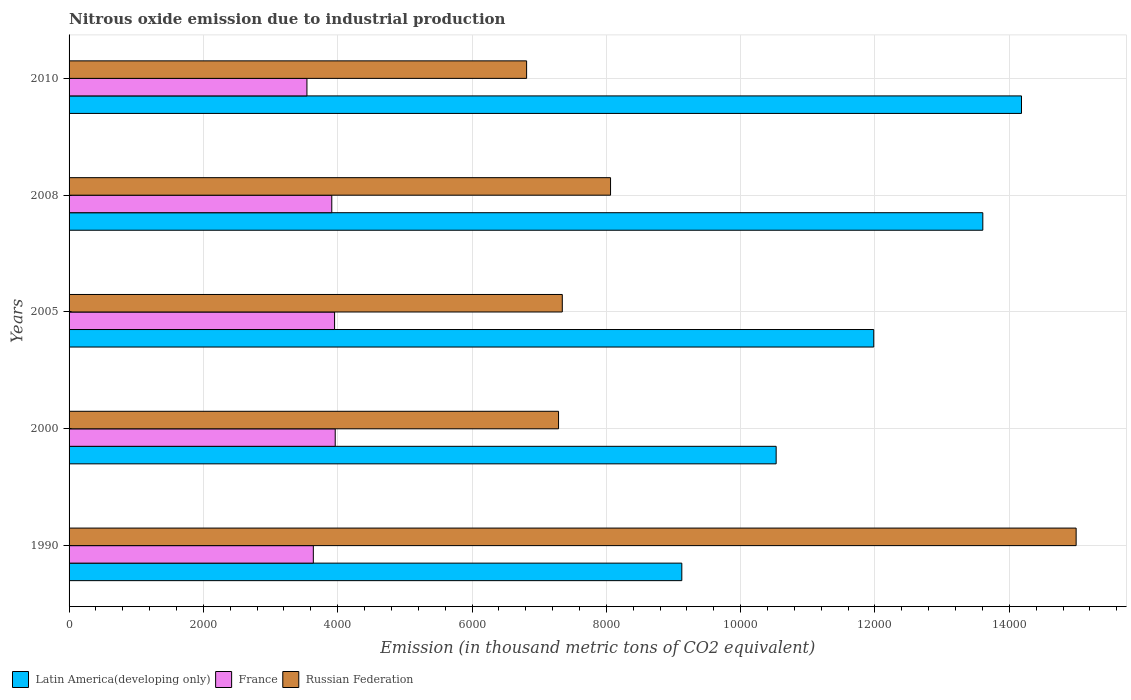How many groups of bars are there?
Make the answer very short. 5. Are the number of bars on each tick of the Y-axis equal?
Provide a succinct answer. Yes. How many bars are there on the 2nd tick from the bottom?
Offer a very short reply. 3. In how many cases, is the number of bars for a given year not equal to the number of legend labels?
Your answer should be very brief. 0. What is the amount of nitrous oxide emitted in Russian Federation in 2000?
Offer a very short reply. 7288.4. Across all years, what is the maximum amount of nitrous oxide emitted in Russian Federation?
Your answer should be very brief. 1.50e+04. Across all years, what is the minimum amount of nitrous oxide emitted in France?
Give a very brief answer. 3541.9. In which year was the amount of nitrous oxide emitted in Latin America(developing only) minimum?
Provide a succinct answer. 1990. What is the total amount of nitrous oxide emitted in Latin America(developing only) in the graph?
Offer a very short reply. 5.94e+04. What is the difference between the amount of nitrous oxide emitted in Latin America(developing only) in 1990 and that in 2005?
Provide a short and direct response. -2858. What is the difference between the amount of nitrous oxide emitted in France in 1990 and the amount of nitrous oxide emitted in Russian Federation in 2008?
Provide a succinct answer. -4425.6. What is the average amount of nitrous oxide emitted in Russian Federation per year?
Offer a terse response. 8900.66. In the year 1990, what is the difference between the amount of nitrous oxide emitted in Latin America(developing only) and amount of nitrous oxide emitted in Russian Federation?
Provide a succinct answer. -5871.5. What is the ratio of the amount of nitrous oxide emitted in France in 2000 to that in 2008?
Make the answer very short. 1.01. What is the difference between the highest and the lowest amount of nitrous oxide emitted in Latin America(developing only)?
Your answer should be very brief. 5058. In how many years, is the amount of nitrous oxide emitted in France greater than the average amount of nitrous oxide emitted in France taken over all years?
Offer a very short reply. 3. What does the 1st bar from the top in 2000 represents?
Keep it short and to the point. Russian Federation. What does the 3rd bar from the bottom in 1990 represents?
Provide a succinct answer. Russian Federation. How many bars are there?
Give a very brief answer. 15. Are the values on the major ticks of X-axis written in scientific E-notation?
Provide a short and direct response. No. Does the graph contain any zero values?
Your response must be concise. No. Does the graph contain grids?
Make the answer very short. Yes. How many legend labels are there?
Offer a terse response. 3. How are the legend labels stacked?
Ensure brevity in your answer.  Horizontal. What is the title of the graph?
Ensure brevity in your answer.  Nitrous oxide emission due to industrial production. What is the label or title of the X-axis?
Ensure brevity in your answer.  Emission (in thousand metric tons of CO2 equivalent). What is the Emission (in thousand metric tons of CO2 equivalent) in Latin America(developing only) in 1990?
Your answer should be compact. 9123.8. What is the Emission (in thousand metric tons of CO2 equivalent) of France in 1990?
Your answer should be compact. 3637.1. What is the Emission (in thousand metric tons of CO2 equivalent) of Russian Federation in 1990?
Offer a very short reply. 1.50e+04. What is the Emission (in thousand metric tons of CO2 equivalent) in Latin America(developing only) in 2000?
Your answer should be very brief. 1.05e+04. What is the Emission (in thousand metric tons of CO2 equivalent) of France in 2000?
Your response must be concise. 3963. What is the Emission (in thousand metric tons of CO2 equivalent) in Russian Federation in 2000?
Offer a terse response. 7288.4. What is the Emission (in thousand metric tons of CO2 equivalent) in Latin America(developing only) in 2005?
Provide a short and direct response. 1.20e+04. What is the Emission (in thousand metric tons of CO2 equivalent) in France in 2005?
Your response must be concise. 3953.5. What is the Emission (in thousand metric tons of CO2 equivalent) in Russian Federation in 2005?
Provide a short and direct response. 7344.1. What is the Emission (in thousand metric tons of CO2 equivalent) in Latin America(developing only) in 2008?
Keep it short and to the point. 1.36e+04. What is the Emission (in thousand metric tons of CO2 equivalent) of France in 2008?
Give a very brief answer. 3911.7. What is the Emission (in thousand metric tons of CO2 equivalent) of Russian Federation in 2008?
Your response must be concise. 8062.7. What is the Emission (in thousand metric tons of CO2 equivalent) in Latin America(developing only) in 2010?
Provide a succinct answer. 1.42e+04. What is the Emission (in thousand metric tons of CO2 equivalent) in France in 2010?
Ensure brevity in your answer.  3541.9. What is the Emission (in thousand metric tons of CO2 equivalent) in Russian Federation in 2010?
Your answer should be very brief. 6812.8. Across all years, what is the maximum Emission (in thousand metric tons of CO2 equivalent) of Latin America(developing only)?
Your response must be concise. 1.42e+04. Across all years, what is the maximum Emission (in thousand metric tons of CO2 equivalent) of France?
Your answer should be compact. 3963. Across all years, what is the maximum Emission (in thousand metric tons of CO2 equivalent) in Russian Federation?
Provide a succinct answer. 1.50e+04. Across all years, what is the minimum Emission (in thousand metric tons of CO2 equivalent) in Latin America(developing only)?
Provide a succinct answer. 9123.8. Across all years, what is the minimum Emission (in thousand metric tons of CO2 equivalent) of France?
Your answer should be compact. 3541.9. Across all years, what is the minimum Emission (in thousand metric tons of CO2 equivalent) of Russian Federation?
Make the answer very short. 6812.8. What is the total Emission (in thousand metric tons of CO2 equivalent) in Latin America(developing only) in the graph?
Provide a succinct answer. 5.94e+04. What is the total Emission (in thousand metric tons of CO2 equivalent) of France in the graph?
Keep it short and to the point. 1.90e+04. What is the total Emission (in thousand metric tons of CO2 equivalent) in Russian Federation in the graph?
Provide a succinct answer. 4.45e+04. What is the difference between the Emission (in thousand metric tons of CO2 equivalent) of Latin America(developing only) in 1990 and that in 2000?
Give a very brief answer. -1404.8. What is the difference between the Emission (in thousand metric tons of CO2 equivalent) of France in 1990 and that in 2000?
Keep it short and to the point. -325.9. What is the difference between the Emission (in thousand metric tons of CO2 equivalent) of Russian Federation in 1990 and that in 2000?
Your response must be concise. 7706.9. What is the difference between the Emission (in thousand metric tons of CO2 equivalent) in Latin America(developing only) in 1990 and that in 2005?
Make the answer very short. -2858. What is the difference between the Emission (in thousand metric tons of CO2 equivalent) of France in 1990 and that in 2005?
Provide a succinct answer. -316.4. What is the difference between the Emission (in thousand metric tons of CO2 equivalent) of Russian Federation in 1990 and that in 2005?
Your answer should be compact. 7651.2. What is the difference between the Emission (in thousand metric tons of CO2 equivalent) of Latin America(developing only) in 1990 and that in 2008?
Your response must be concise. -4481.8. What is the difference between the Emission (in thousand metric tons of CO2 equivalent) in France in 1990 and that in 2008?
Your answer should be very brief. -274.6. What is the difference between the Emission (in thousand metric tons of CO2 equivalent) in Russian Federation in 1990 and that in 2008?
Offer a terse response. 6932.6. What is the difference between the Emission (in thousand metric tons of CO2 equivalent) in Latin America(developing only) in 1990 and that in 2010?
Give a very brief answer. -5058. What is the difference between the Emission (in thousand metric tons of CO2 equivalent) in France in 1990 and that in 2010?
Make the answer very short. 95.2. What is the difference between the Emission (in thousand metric tons of CO2 equivalent) of Russian Federation in 1990 and that in 2010?
Your answer should be compact. 8182.5. What is the difference between the Emission (in thousand metric tons of CO2 equivalent) of Latin America(developing only) in 2000 and that in 2005?
Provide a short and direct response. -1453.2. What is the difference between the Emission (in thousand metric tons of CO2 equivalent) in Russian Federation in 2000 and that in 2005?
Your response must be concise. -55.7. What is the difference between the Emission (in thousand metric tons of CO2 equivalent) of Latin America(developing only) in 2000 and that in 2008?
Ensure brevity in your answer.  -3077. What is the difference between the Emission (in thousand metric tons of CO2 equivalent) in France in 2000 and that in 2008?
Offer a terse response. 51.3. What is the difference between the Emission (in thousand metric tons of CO2 equivalent) of Russian Federation in 2000 and that in 2008?
Offer a very short reply. -774.3. What is the difference between the Emission (in thousand metric tons of CO2 equivalent) in Latin America(developing only) in 2000 and that in 2010?
Provide a short and direct response. -3653.2. What is the difference between the Emission (in thousand metric tons of CO2 equivalent) in France in 2000 and that in 2010?
Keep it short and to the point. 421.1. What is the difference between the Emission (in thousand metric tons of CO2 equivalent) of Russian Federation in 2000 and that in 2010?
Give a very brief answer. 475.6. What is the difference between the Emission (in thousand metric tons of CO2 equivalent) in Latin America(developing only) in 2005 and that in 2008?
Make the answer very short. -1623.8. What is the difference between the Emission (in thousand metric tons of CO2 equivalent) of France in 2005 and that in 2008?
Keep it short and to the point. 41.8. What is the difference between the Emission (in thousand metric tons of CO2 equivalent) of Russian Federation in 2005 and that in 2008?
Make the answer very short. -718.6. What is the difference between the Emission (in thousand metric tons of CO2 equivalent) of Latin America(developing only) in 2005 and that in 2010?
Give a very brief answer. -2200. What is the difference between the Emission (in thousand metric tons of CO2 equivalent) in France in 2005 and that in 2010?
Offer a very short reply. 411.6. What is the difference between the Emission (in thousand metric tons of CO2 equivalent) of Russian Federation in 2005 and that in 2010?
Offer a very short reply. 531.3. What is the difference between the Emission (in thousand metric tons of CO2 equivalent) in Latin America(developing only) in 2008 and that in 2010?
Give a very brief answer. -576.2. What is the difference between the Emission (in thousand metric tons of CO2 equivalent) in France in 2008 and that in 2010?
Make the answer very short. 369.8. What is the difference between the Emission (in thousand metric tons of CO2 equivalent) of Russian Federation in 2008 and that in 2010?
Offer a terse response. 1249.9. What is the difference between the Emission (in thousand metric tons of CO2 equivalent) of Latin America(developing only) in 1990 and the Emission (in thousand metric tons of CO2 equivalent) of France in 2000?
Your answer should be very brief. 5160.8. What is the difference between the Emission (in thousand metric tons of CO2 equivalent) of Latin America(developing only) in 1990 and the Emission (in thousand metric tons of CO2 equivalent) of Russian Federation in 2000?
Your answer should be compact. 1835.4. What is the difference between the Emission (in thousand metric tons of CO2 equivalent) in France in 1990 and the Emission (in thousand metric tons of CO2 equivalent) in Russian Federation in 2000?
Keep it short and to the point. -3651.3. What is the difference between the Emission (in thousand metric tons of CO2 equivalent) of Latin America(developing only) in 1990 and the Emission (in thousand metric tons of CO2 equivalent) of France in 2005?
Provide a short and direct response. 5170.3. What is the difference between the Emission (in thousand metric tons of CO2 equivalent) in Latin America(developing only) in 1990 and the Emission (in thousand metric tons of CO2 equivalent) in Russian Federation in 2005?
Your answer should be compact. 1779.7. What is the difference between the Emission (in thousand metric tons of CO2 equivalent) in France in 1990 and the Emission (in thousand metric tons of CO2 equivalent) in Russian Federation in 2005?
Provide a succinct answer. -3707. What is the difference between the Emission (in thousand metric tons of CO2 equivalent) in Latin America(developing only) in 1990 and the Emission (in thousand metric tons of CO2 equivalent) in France in 2008?
Keep it short and to the point. 5212.1. What is the difference between the Emission (in thousand metric tons of CO2 equivalent) of Latin America(developing only) in 1990 and the Emission (in thousand metric tons of CO2 equivalent) of Russian Federation in 2008?
Provide a short and direct response. 1061.1. What is the difference between the Emission (in thousand metric tons of CO2 equivalent) of France in 1990 and the Emission (in thousand metric tons of CO2 equivalent) of Russian Federation in 2008?
Give a very brief answer. -4425.6. What is the difference between the Emission (in thousand metric tons of CO2 equivalent) in Latin America(developing only) in 1990 and the Emission (in thousand metric tons of CO2 equivalent) in France in 2010?
Your response must be concise. 5581.9. What is the difference between the Emission (in thousand metric tons of CO2 equivalent) of Latin America(developing only) in 1990 and the Emission (in thousand metric tons of CO2 equivalent) of Russian Federation in 2010?
Provide a succinct answer. 2311. What is the difference between the Emission (in thousand metric tons of CO2 equivalent) of France in 1990 and the Emission (in thousand metric tons of CO2 equivalent) of Russian Federation in 2010?
Your answer should be very brief. -3175.7. What is the difference between the Emission (in thousand metric tons of CO2 equivalent) in Latin America(developing only) in 2000 and the Emission (in thousand metric tons of CO2 equivalent) in France in 2005?
Make the answer very short. 6575.1. What is the difference between the Emission (in thousand metric tons of CO2 equivalent) in Latin America(developing only) in 2000 and the Emission (in thousand metric tons of CO2 equivalent) in Russian Federation in 2005?
Ensure brevity in your answer.  3184.5. What is the difference between the Emission (in thousand metric tons of CO2 equivalent) in France in 2000 and the Emission (in thousand metric tons of CO2 equivalent) in Russian Federation in 2005?
Your answer should be very brief. -3381.1. What is the difference between the Emission (in thousand metric tons of CO2 equivalent) in Latin America(developing only) in 2000 and the Emission (in thousand metric tons of CO2 equivalent) in France in 2008?
Provide a succinct answer. 6616.9. What is the difference between the Emission (in thousand metric tons of CO2 equivalent) in Latin America(developing only) in 2000 and the Emission (in thousand metric tons of CO2 equivalent) in Russian Federation in 2008?
Give a very brief answer. 2465.9. What is the difference between the Emission (in thousand metric tons of CO2 equivalent) in France in 2000 and the Emission (in thousand metric tons of CO2 equivalent) in Russian Federation in 2008?
Offer a terse response. -4099.7. What is the difference between the Emission (in thousand metric tons of CO2 equivalent) in Latin America(developing only) in 2000 and the Emission (in thousand metric tons of CO2 equivalent) in France in 2010?
Provide a short and direct response. 6986.7. What is the difference between the Emission (in thousand metric tons of CO2 equivalent) of Latin America(developing only) in 2000 and the Emission (in thousand metric tons of CO2 equivalent) of Russian Federation in 2010?
Your answer should be compact. 3715.8. What is the difference between the Emission (in thousand metric tons of CO2 equivalent) in France in 2000 and the Emission (in thousand metric tons of CO2 equivalent) in Russian Federation in 2010?
Give a very brief answer. -2849.8. What is the difference between the Emission (in thousand metric tons of CO2 equivalent) of Latin America(developing only) in 2005 and the Emission (in thousand metric tons of CO2 equivalent) of France in 2008?
Keep it short and to the point. 8070.1. What is the difference between the Emission (in thousand metric tons of CO2 equivalent) of Latin America(developing only) in 2005 and the Emission (in thousand metric tons of CO2 equivalent) of Russian Federation in 2008?
Your answer should be compact. 3919.1. What is the difference between the Emission (in thousand metric tons of CO2 equivalent) in France in 2005 and the Emission (in thousand metric tons of CO2 equivalent) in Russian Federation in 2008?
Your response must be concise. -4109.2. What is the difference between the Emission (in thousand metric tons of CO2 equivalent) of Latin America(developing only) in 2005 and the Emission (in thousand metric tons of CO2 equivalent) of France in 2010?
Your response must be concise. 8439.9. What is the difference between the Emission (in thousand metric tons of CO2 equivalent) in Latin America(developing only) in 2005 and the Emission (in thousand metric tons of CO2 equivalent) in Russian Federation in 2010?
Make the answer very short. 5169. What is the difference between the Emission (in thousand metric tons of CO2 equivalent) of France in 2005 and the Emission (in thousand metric tons of CO2 equivalent) of Russian Federation in 2010?
Provide a short and direct response. -2859.3. What is the difference between the Emission (in thousand metric tons of CO2 equivalent) in Latin America(developing only) in 2008 and the Emission (in thousand metric tons of CO2 equivalent) in France in 2010?
Offer a very short reply. 1.01e+04. What is the difference between the Emission (in thousand metric tons of CO2 equivalent) in Latin America(developing only) in 2008 and the Emission (in thousand metric tons of CO2 equivalent) in Russian Federation in 2010?
Ensure brevity in your answer.  6792.8. What is the difference between the Emission (in thousand metric tons of CO2 equivalent) of France in 2008 and the Emission (in thousand metric tons of CO2 equivalent) of Russian Federation in 2010?
Offer a terse response. -2901.1. What is the average Emission (in thousand metric tons of CO2 equivalent) of Latin America(developing only) per year?
Provide a succinct answer. 1.19e+04. What is the average Emission (in thousand metric tons of CO2 equivalent) of France per year?
Give a very brief answer. 3801.44. What is the average Emission (in thousand metric tons of CO2 equivalent) in Russian Federation per year?
Your answer should be very brief. 8900.66. In the year 1990, what is the difference between the Emission (in thousand metric tons of CO2 equivalent) of Latin America(developing only) and Emission (in thousand metric tons of CO2 equivalent) of France?
Give a very brief answer. 5486.7. In the year 1990, what is the difference between the Emission (in thousand metric tons of CO2 equivalent) of Latin America(developing only) and Emission (in thousand metric tons of CO2 equivalent) of Russian Federation?
Your response must be concise. -5871.5. In the year 1990, what is the difference between the Emission (in thousand metric tons of CO2 equivalent) of France and Emission (in thousand metric tons of CO2 equivalent) of Russian Federation?
Keep it short and to the point. -1.14e+04. In the year 2000, what is the difference between the Emission (in thousand metric tons of CO2 equivalent) in Latin America(developing only) and Emission (in thousand metric tons of CO2 equivalent) in France?
Your response must be concise. 6565.6. In the year 2000, what is the difference between the Emission (in thousand metric tons of CO2 equivalent) in Latin America(developing only) and Emission (in thousand metric tons of CO2 equivalent) in Russian Federation?
Your answer should be compact. 3240.2. In the year 2000, what is the difference between the Emission (in thousand metric tons of CO2 equivalent) of France and Emission (in thousand metric tons of CO2 equivalent) of Russian Federation?
Keep it short and to the point. -3325.4. In the year 2005, what is the difference between the Emission (in thousand metric tons of CO2 equivalent) in Latin America(developing only) and Emission (in thousand metric tons of CO2 equivalent) in France?
Provide a short and direct response. 8028.3. In the year 2005, what is the difference between the Emission (in thousand metric tons of CO2 equivalent) in Latin America(developing only) and Emission (in thousand metric tons of CO2 equivalent) in Russian Federation?
Offer a terse response. 4637.7. In the year 2005, what is the difference between the Emission (in thousand metric tons of CO2 equivalent) of France and Emission (in thousand metric tons of CO2 equivalent) of Russian Federation?
Your answer should be compact. -3390.6. In the year 2008, what is the difference between the Emission (in thousand metric tons of CO2 equivalent) in Latin America(developing only) and Emission (in thousand metric tons of CO2 equivalent) in France?
Keep it short and to the point. 9693.9. In the year 2008, what is the difference between the Emission (in thousand metric tons of CO2 equivalent) of Latin America(developing only) and Emission (in thousand metric tons of CO2 equivalent) of Russian Federation?
Keep it short and to the point. 5542.9. In the year 2008, what is the difference between the Emission (in thousand metric tons of CO2 equivalent) in France and Emission (in thousand metric tons of CO2 equivalent) in Russian Federation?
Your answer should be very brief. -4151. In the year 2010, what is the difference between the Emission (in thousand metric tons of CO2 equivalent) of Latin America(developing only) and Emission (in thousand metric tons of CO2 equivalent) of France?
Give a very brief answer. 1.06e+04. In the year 2010, what is the difference between the Emission (in thousand metric tons of CO2 equivalent) of Latin America(developing only) and Emission (in thousand metric tons of CO2 equivalent) of Russian Federation?
Provide a short and direct response. 7369. In the year 2010, what is the difference between the Emission (in thousand metric tons of CO2 equivalent) in France and Emission (in thousand metric tons of CO2 equivalent) in Russian Federation?
Offer a terse response. -3270.9. What is the ratio of the Emission (in thousand metric tons of CO2 equivalent) of Latin America(developing only) in 1990 to that in 2000?
Your response must be concise. 0.87. What is the ratio of the Emission (in thousand metric tons of CO2 equivalent) of France in 1990 to that in 2000?
Your response must be concise. 0.92. What is the ratio of the Emission (in thousand metric tons of CO2 equivalent) in Russian Federation in 1990 to that in 2000?
Keep it short and to the point. 2.06. What is the ratio of the Emission (in thousand metric tons of CO2 equivalent) of Latin America(developing only) in 1990 to that in 2005?
Offer a very short reply. 0.76. What is the ratio of the Emission (in thousand metric tons of CO2 equivalent) of Russian Federation in 1990 to that in 2005?
Your answer should be compact. 2.04. What is the ratio of the Emission (in thousand metric tons of CO2 equivalent) in Latin America(developing only) in 1990 to that in 2008?
Give a very brief answer. 0.67. What is the ratio of the Emission (in thousand metric tons of CO2 equivalent) of France in 1990 to that in 2008?
Offer a terse response. 0.93. What is the ratio of the Emission (in thousand metric tons of CO2 equivalent) in Russian Federation in 1990 to that in 2008?
Provide a short and direct response. 1.86. What is the ratio of the Emission (in thousand metric tons of CO2 equivalent) of Latin America(developing only) in 1990 to that in 2010?
Make the answer very short. 0.64. What is the ratio of the Emission (in thousand metric tons of CO2 equivalent) of France in 1990 to that in 2010?
Give a very brief answer. 1.03. What is the ratio of the Emission (in thousand metric tons of CO2 equivalent) in Russian Federation in 1990 to that in 2010?
Offer a terse response. 2.2. What is the ratio of the Emission (in thousand metric tons of CO2 equivalent) of Latin America(developing only) in 2000 to that in 2005?
Make the answer very short. 0.88. What is the ratio of the Emission (in thousand metric tons of CO2 equivalent) of Latin America(developing only) in 2000 to that in 2008?
Your answer should be compact. 0.77. What is the ratio of the Emission (in thousand metric tons of CO2 equivalent) of France in 2000 to that in 2008?
Your answer should be very brief. 1.01. What is the ratio of the Emission (in thousand metric tons of CO2 equivalent) in Russian Federation in 2000 to that in 2008?
Provide a short and direct response. 0.9. What is the ratio of the Emission (in thousand metric tons of CO2 equivalent) of Latin America(developing only) in 2000 to that in 2010?
Provide a short and direct response. 0.74. What is the ratio of the Emission (in thousand metric tons of CO2 equivalent) in France in 2000 to that in 2010?
Keep it short and to the point. 1.12. What is the ratio of the Emission (in thousand metric tons of CO2 equivalent) in Russian Federation in 2000 to that in 2010?
Provide a short and direct response. 1.07. What is the ratio of the Emission (in thousand metric tons of CO2 equivalent) of Latin America(developing only) in 2005 to that in 2008?
Provide a short and direct response. 0.88. What is the ratio of the Emission (in thousand metric tons of CO2 equivalent) in France in 2005 to that in 2008?
Give a very brief answer. 1.01. What is the ratio of the Emission (in thousand metric tons of CO2 equivalent) in Russian Federation in 2005 to that in 2008?
Provide a succinct answer. 0.91. What is the ratio of the Emission (in thousand metric tons of CO2 equivalent) in Latin America(developing only) in 2005 to that in 2010?
Give a very brief answer. 0.84. What is the ratio of the Emission (in thousand metric tons of CO2 equivalent) in France in 2005 to that in 2010?
Your response must be concise. 1.12. What is the ratio of the Emission (in thousand metric tons of CO2 equivalent) of Russian Federation in 2005 to that in 2010?
Provide a short and direct response. 1.08. What is the ratio of the Emission (in thousand metric tons of CO2 equivalent) of Latin America(developing only) in 2008 to that in 2010?
Give a very brief answer. 0.96. What is the ratio of the Emission (in thousand metric tons of CO2 equivalent) in France in 2008 to that in 2010?
Provide a short and direct response. 1.1. What is the ratio of the Emission (in thousand metric tons of CO2 equivalent) in Russian Federation in 2008 to that in 2010?
Your response must be concise. 1.18. What is the difference between the highest and the second highest Emission (in thousand metric tons of CO2 equivalent) in Latin America(developing only)?
Offer a very short reply. 576.2. What is the difference between the highest and the second highest Emission (in thousand metric tons of CO2 equivalent) in France?
Your answer should be very brief. 9.5. What is the difference between the highest and the second highest Emission (in thousand metric tons of CO2 equivalent) in Russian Federation?
Your answer should be very brief. 6932.6. What is the difference between the highest and the lowest Emission (in thousand metric tons of CO2 equivalent) of Latin America(developing only)?
Give a very brief answer. 5058. What is the difference between the highest and the lowest Emission (in thousand metric tons of CO2 equivalent) of France?
Your answer should be compact. 421.1. What is the difference between the highest and the lowest Emission (in thousand metric tons of CO2 equivalent) of Russian Federation?
Give a very brief answer. 8182.5. 